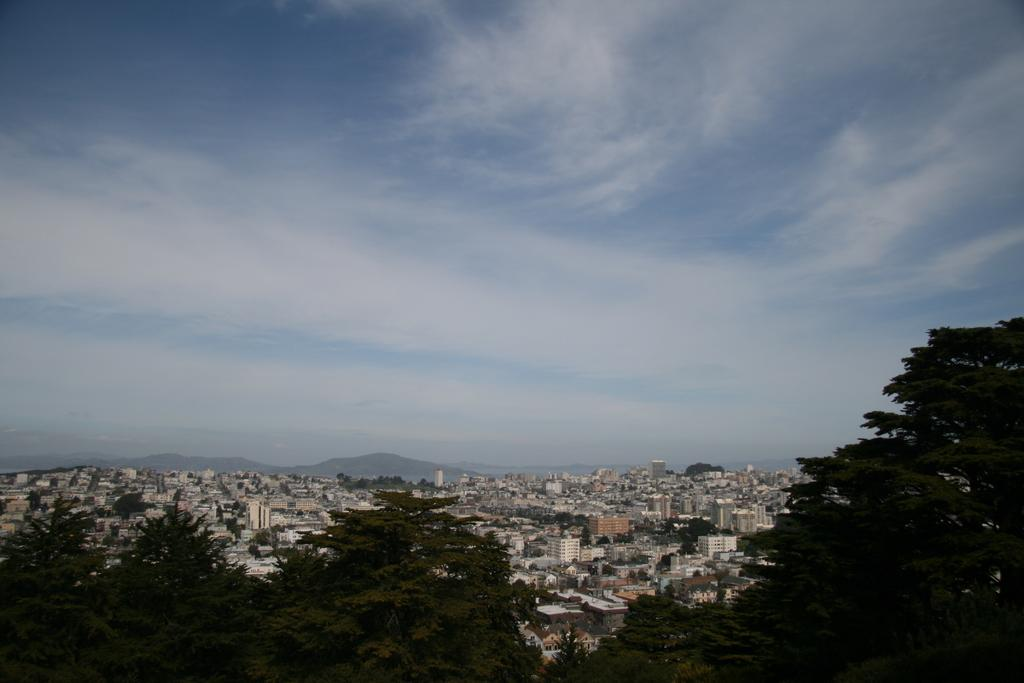What type of setting is depicted in the image? The image is an outside view. What can be seen in the image besides the sky? There are many trees and buildings in the image. What is visible at the top of the image? The sky is visible at the top of the image. What can be observed in the sky? Clouds are present in the sky. Can you hear the wilderness crying in the image? There is no audible element in the image, and the term "wilderness" is not mentioned or depicted in the image. 